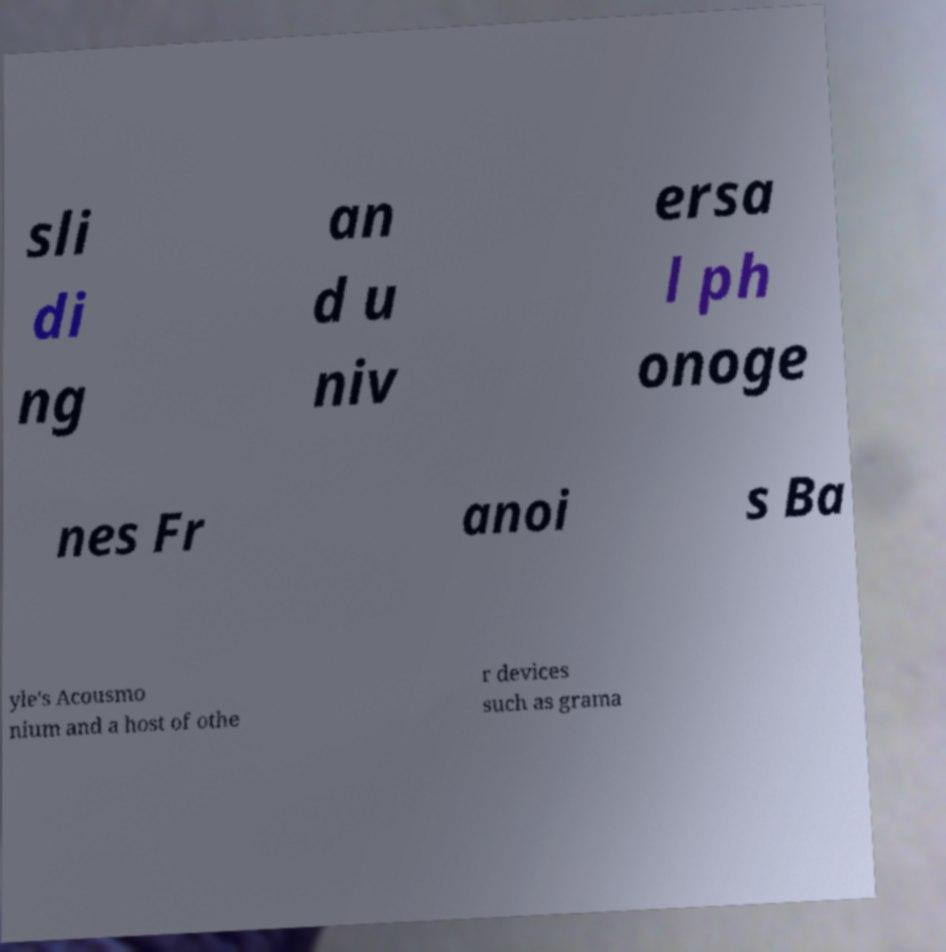I need the written content from this picture converted into text. Can you do that? sli di ng an d u niv ersa l ph onoge nes Fr anoi s Ba yle's Acousmo nium and a host of othe r devices such as grama 